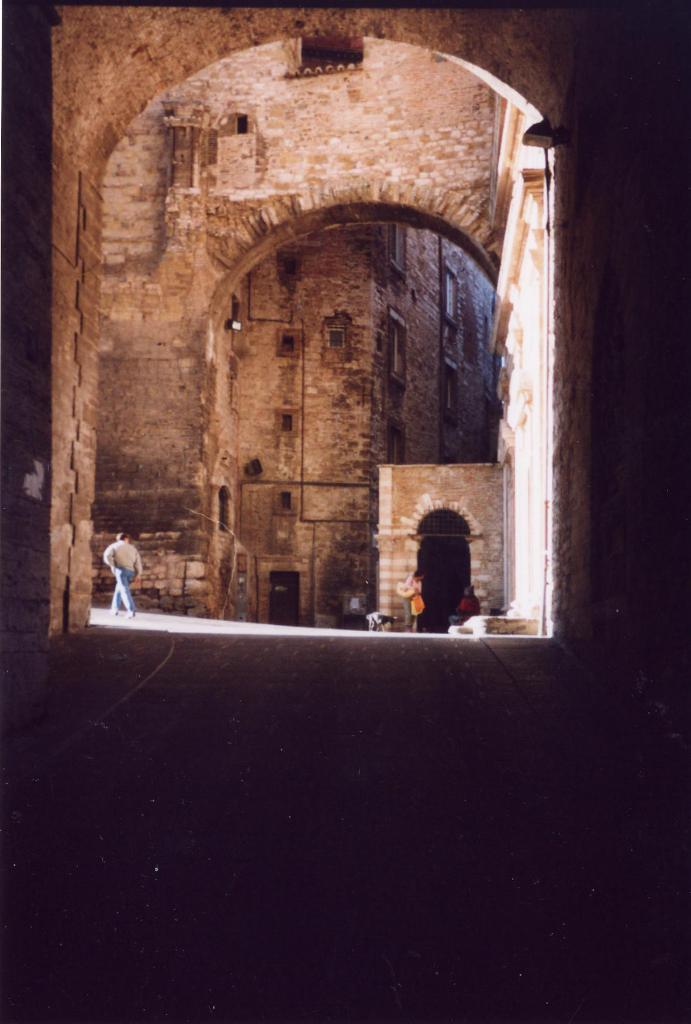What is happening in the image? There is a person in the image, and they are walking. What is the person wearing? The person is wearing a brown shirt and blue pants. What can be seen in the background of the image? There is a building in the background of the image. What color is the building? The building is brown in color. How many pigs are visible in the image? There are no pigs present in the image. What type of fuel is being used by the person in the image? There is no indication of any fuel being used in the image, as the person is simply walking. 